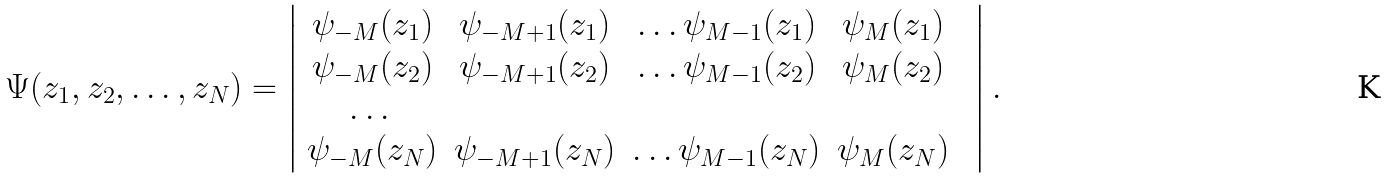<formula> <loc_0><loc_0><loc_500><loc_500>\Psi ( z _ { 1 } , z _ { 2 } , \dots , z _ { N } ) = \left | \begin{array} { c c c c c } \psi _ { - M } ( z _ { 1 } ) & \psi _ { - M + 1 } ( z _ { 1 } ) & \dots \psi _ { M - 1 } ( z _ { 1 } ) & \psi _ { M } ( z _ { 1 } ) \\ \psi _ { - M } ( z _ { 2 } ) & \psi _ { - M + 1 } ( z _ { 2 } ) & \dots \psi _ { M - 1 } ( z _ { 2 } ) & \psi _ { M } ( z _ { 2 } ) \\ \dots & & & & \\ \psi _ { - M } ( z _ { N } ) & \psi _ { - M + 1 } ( z _ { N } ) & \dots \psi _ { M - 1 } ( z _ { N } ) & \psi _ { M } ( z _ { N } ) \\ \end{array} \right | .</formula> 